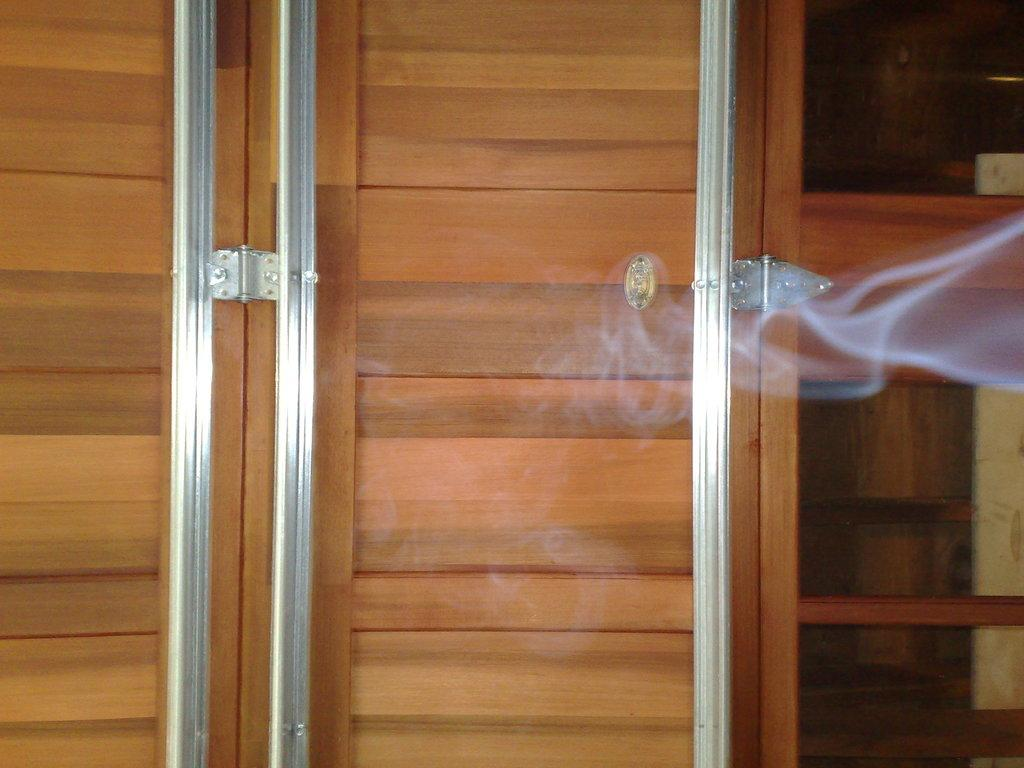What type of door is visible in the image? There is a wooden door in the image. Can you describe anything else present on the right side of the image? Yes, there is smoke on the right side of the image. What type of pickle is being used to open the door in the image? There is no pickle present in the image, and pickles are not used to open doors. 